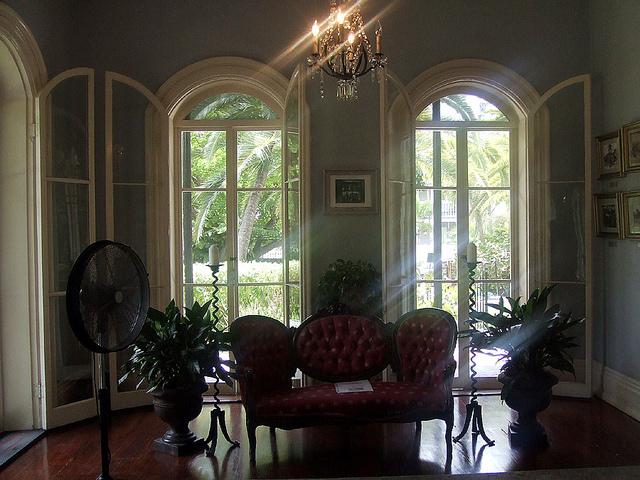How many potted plants do you see?
Keep it brief. 3. How many chairs are there?
Write a very short answer. 1. Is this an old building?
Write a very short answer. Yes. What room is this?
Keep it brief. Living room. Is the room almost full?
Answer briefly. No. 